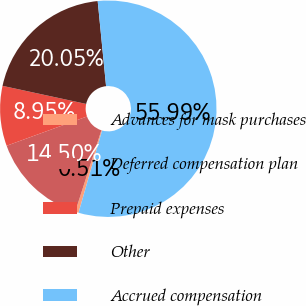Convert chart. <chart><loc_0><loc_0><loc_500><loc_500><pie_chart><fcel>Advances for mask purchases<fcel>Deferred compensation plan<fcel>Prepaid expenses<fcel>Other<fcel>Accrued compensation<nl><fcel>0.51%<fcel>14.5%<fcel>8.95%<fcel>20.05%<fcel>56.0%<nl></chart> 